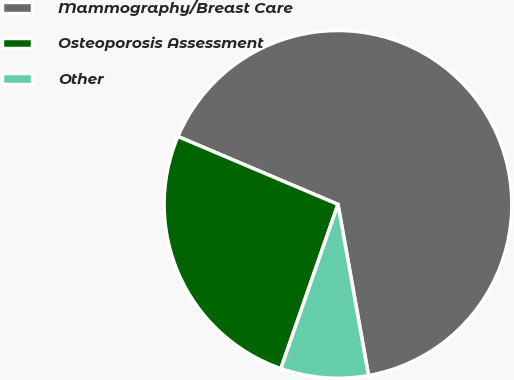Convert chart to OTSL. <chart><loc_0><loc_0><loc_500><loc_500><pie_chart><fcel>Mammography/Breast Care<fcel>Osteoporosis Assessment<fcel>Other<nl><fcel>65.81%<fcel>26.06%<fcel>8.14%<nl></chart> 